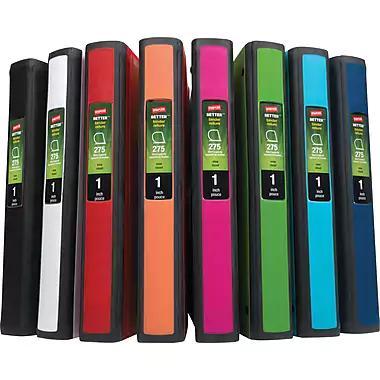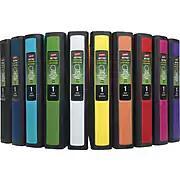The first image is the image on the left, the second image is the image on the right. Considering the images on both sides, is "One image shows different colored binders displayed at some angle, instead of curved or straight ahead." valid? Answer yes or no. No. The first image is the image on the left, the second image is the image on the right. For the images displayed, is the sentence "In one of the pictures, the white binder is between the black and red binders." factually correct? Answer yes or no. Yes. 